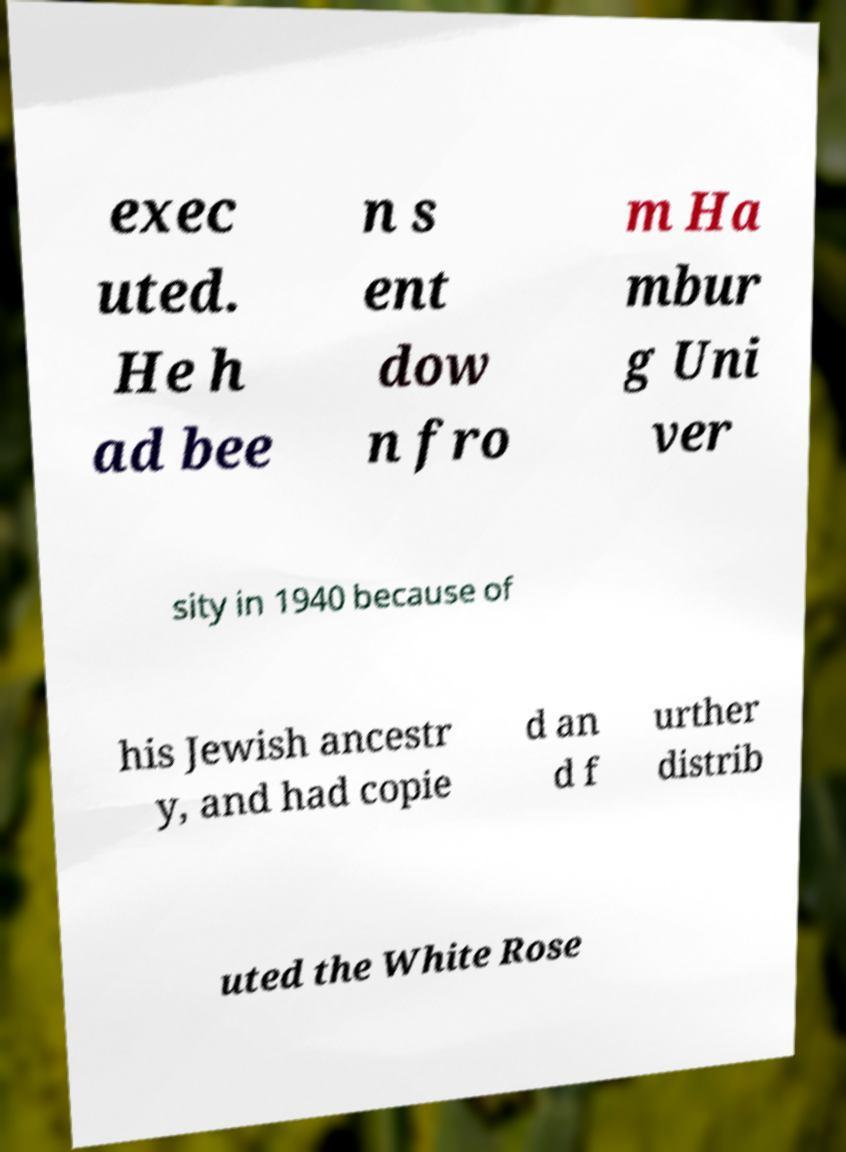Could you extract and type out the text from this image? exec uted. He h ad bee n s ent dow n fro m Ha mbur g Uni ver sity in 1940 because of his Jewish ancestr y, and had copie d an d f urther distrib uted the White Rose 